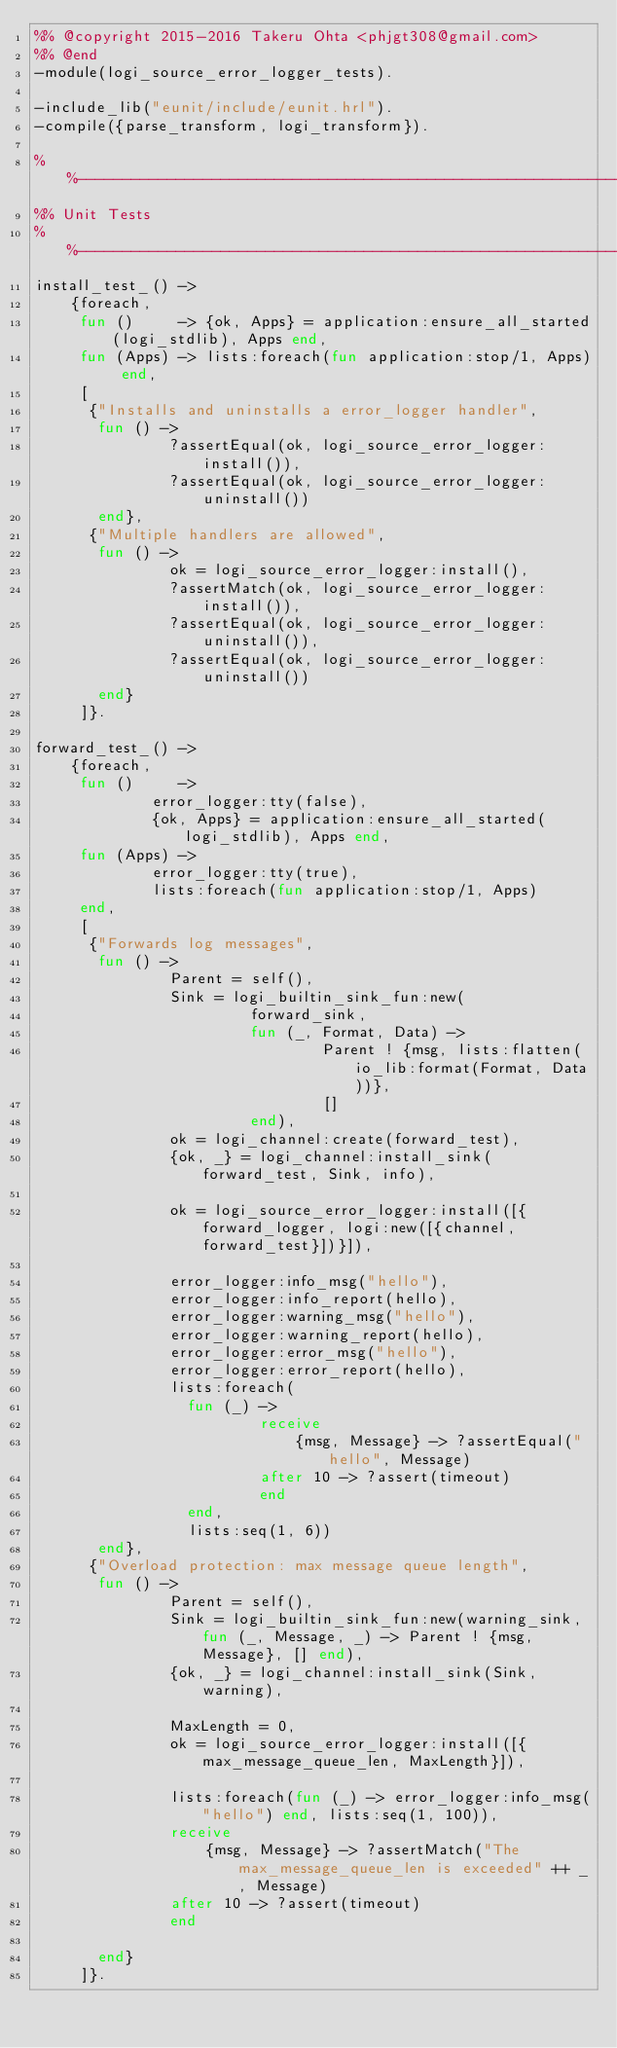Convert code to text. <code><loc_0><loc_0><loc_500><loc_500><_Erlang_>%% @copyright 2015-2016 Takeru Ohta <phjgt308@gmail.com>
%% @end
-module(logi_source_error_logger_tests).

-include_lib("eunit/include/eunit.hrl").
-compile({parse_transform, logi_transform}).

%%----------------------------------------------------------------------------------------------------------------------
%% Unit Tests
%%----------------------------------------------------------------------------------------------------------------------
install_test_() ->
    {foreach,
     fun ()     -> {ok, Apps} = application:ensure_all_started(logi_stdlib), Apps end,
     fun (Apps) -> lists:foreach(fun application:stop/1, Apps) end,
     [
      {"Installs and uninstalls a error_logger handler",
       fun () ->
               ?assertEqual(ok, logi_source_error_logger:install()),
               ?assertEqual(ok, logi_source_error_logger:uninstall())
       end},
      {"Multiple handlers are allowed",
       fun () ->
               ok = logi_source_error_logger:install(),
               ?assertMatch(ok, logi_source_error_logger:install()),
               ?assertEqual(ok, logi_source_error_logger:uninstall()),
               ?assertEqual(ok, logi_source_error_logger:uninstall())
       end}
     ]}.

forward_test_() ->
    {foreach,
     fun ()     ->
             error_logger:tty(false),
             {ok, Apps} = application:ensure_all_started(logi_stdlib), Apps end,
     fun (Apps) ->
             error_logger:tty(true),
             lists:foreach(fun application:stop/1, Apps)
     end,
     [
      {"Forwards log messages",
       fun () ->
               Parent = self(),
               Sink = logi_builtin_sink_fun:new(
                        forward_sink,
                        fun (_, Format, Data) ->
                                Parent ! {msg, lists:flatten(io_lib:format(Format, Data))},
                                []
                        end),
               ok = logi_channel:create(forward_test),
               {ok, _} = logi_channel:install_sink(forward_test, Sink, info),

               ok = logi_source_error_logger:install([{forward_logger, logi:new([{channel, forward_test}])}]),

               error_logger:info_msg("hello"),
               error_logger:info_report(hello),
               error_logger:warning_msg("hello"),
               error_logger:warning_report(hello),
               error_logger:error_msg("hello"),
               error_logger:error_report(hello),
               lists:foreach(
                 fun (_) ->
                         receive
                             {msg, Message} -> ?assertEqual("hello", Message)
                         after 10 -> ?assert(timeout)
                         end
                 end,
                 lists:seq(1, 6))
       end},
      {"Overload protection: max message queue length",
       fun () ->
               Parent = self(),
               Sink = logi_builtin_sink_fun:new(warning_sink, fun (_, Message, _) -> Parent ! {msg, Message}, [] end),
               {ok, _} = logi_channel:install_sink(Sink, warning),

               MaxLength = 0,
               ok = logi_source_error_logger:install([{max_message_queue_len, MaxLength}]),

               lists:foreach(fun (_) -> error_logger:info_msg("hello") end, lists:seq(1, 100)),
               receive
                   {msg, Message} -> ?assertMatch("The max_message_queue_len is exceeded" ++ _, Message)
               after 10 -> ?assert(timeout)
               end

       end}
     ]}.
</code> 